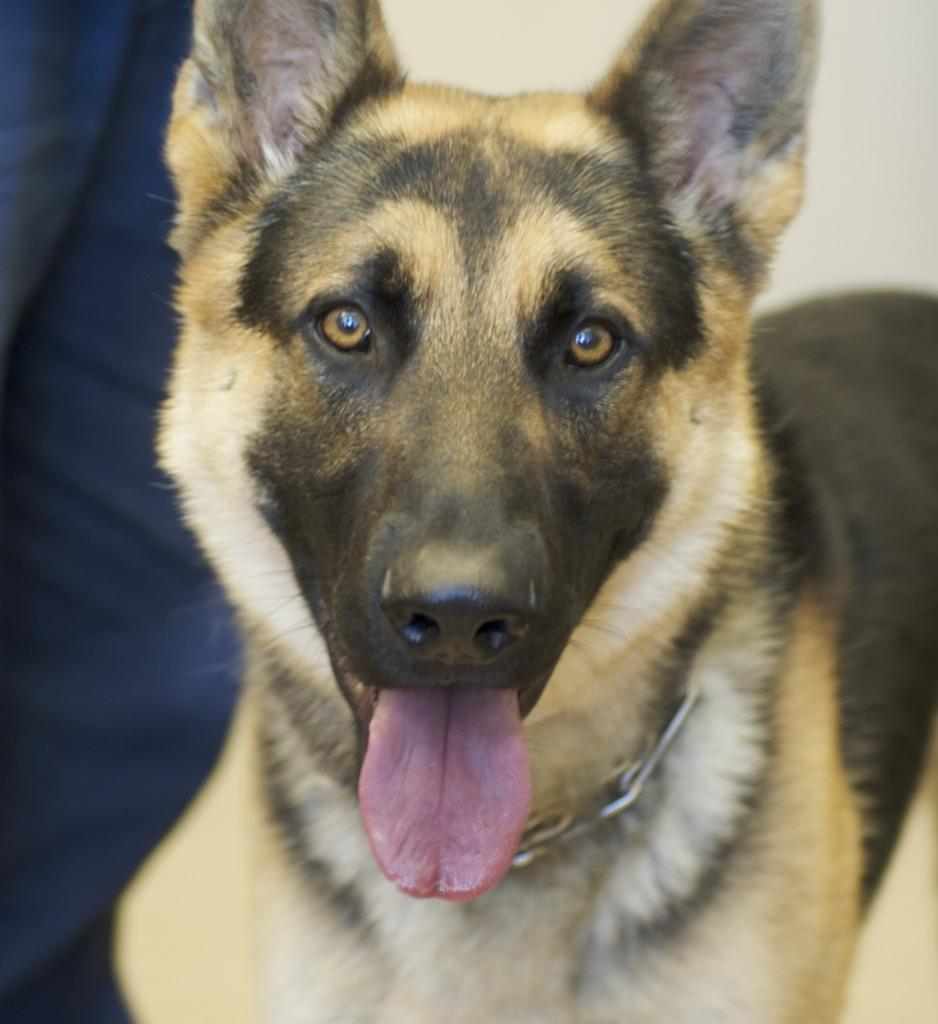What type of animal is in the image? There is a dog in the image. Can you describe the colors of the dog? The dog has brown, black, and white colors. What is the color of the background in the image? The background of the image is white. What type of cracker is the dog using to lift heavy objects in the image? There is no cracker or heavy objects present in the image, and the dog is not performing any lifting actions. 